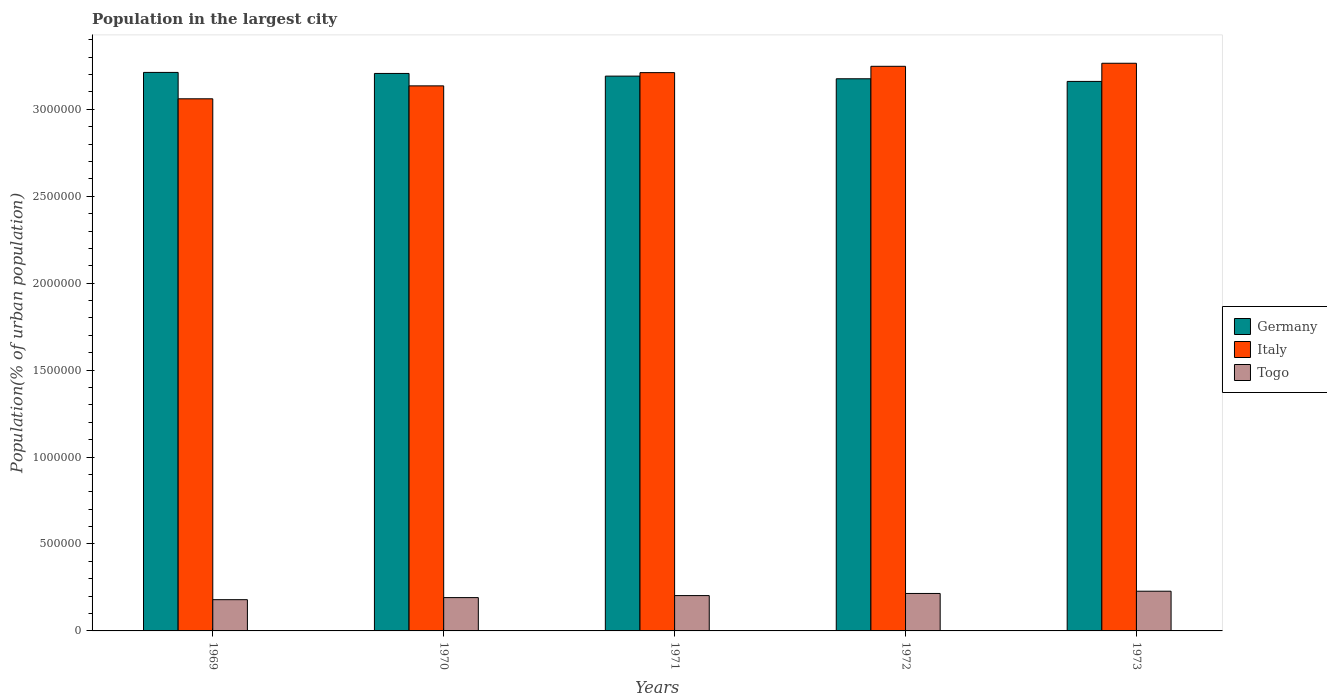How many groups of bars are there?
Your response must be concise. 5. Are the number of bars per tick equal to the number of legend labels?
Make the answer very short. Yes. Are the number of bars on each tick of the X-axis equal?
Offer a terse response. Yes. How many bars are there on the 1st tick from the right?
Your answer should be very brief. 3. In how many cases, is the number of bars for a given year not equal to the number of legend labels?
Keep it short and to the point. 0. What is the population in the largest city in Italy in 1971?
Make the answer very short. 3.21e+06. Across all years, what is the maximum population in the largest city in Italy?
Your answer should be very brief. 3.26e+06. Across all years, what is the minimum population in the largest city in Togo?
Offer a terse response. 1.80e+05. In which year was the population in the largest city in Italy minimum?
Offer a very short reply. 1969. What is the total population in the largest city in Togo in the graph?
Ensure brevity in your answer.  1.02e+06. What is the difference between the population in the largest city in Germany in 1970 and that in 1972?
Make the answer very short. 3.06e+04. What is the difference between the population in the largest city in Togo in 1973 and the population in the largest city in Italy in 1971?
Make the answer very short. -2.98e+06. What is the average population in the largest city in Germany per year?
Offer a terse response. 3.19e+06. In the year 1973, what is the difference between the population in the largest city in Togo and population in the largest city in Germany?
Give a very brief answer. -2.93e+06. What is the ratio of the population in the largest city in Italy in 1969 to that in 1972?
Your answer should be compact. 0.94. What is the difference between the highest and the second highest population in the largest city in Germany?
Keep it short and to the point. 5972. What is the difference between the highest and the lowest population in the largest city in Togo?
Keep it short and to the point. 4.87e+04. What does the 3rd bar from the left in 1970 represents?
Offer a very short reply. Togo. What does the 1st bar from the right in 1970 represents?
Your answer should be compact. Togo. How many years are there in the graph?
Provide a succinct answer. 5. What is the difference between two consecutive major ticks on the Y-axis?
Keep it short and to the point. 5.00e+05. Where does the legend appear in the graph?
Your answer should be compact. Center right. How are the legend labels stacked?
Provide a short and direct response. Vertical. What is the title of the graph?
Ensure brevity in your answer.  Population in the largest city. What is the label or title of the X-axis?
Ensure brevity in your answer.  Years. What is the label or title of the Y-axis?
Offer a very short reply. Population(% of urban population). What is the Population(% of urban population) in Germany in 1969?
Keep it short and to the point. 3.21e+06. What is the Population(% of urban population) of Italy in 1969?
Your response must be concise. 3.06e+06. What is the Population(% of urban population) in Togo in 1969?
Your answer should be compact. 1.80e+05. What is the Population(% of urban population) of Germany in 1970?
Keep it short and to the point. 3.21e+06. What is the Population(% of urban population) of Italy in 1970?
Make the answer very short. 3.13e+06. What is the Population(% of urban population) in Togo in 1970?
Offer a very short reply. 1.92e+05. What is the Population(% of urban population) of Germany in 1971?
Offer a terse response. 3.19e+06. What is the Population(% of urban population) of Italy in 1971?
Make the answer very short. 3.21e+06. What is the Population(% of urban population) of Togo in 1971?
Provide a short and direct response. 2.03e+05. What is the Population(% of urban population) of Germany in 1972?
Keep it short and to the point. 3.18e+06. What is the Population(% of urban population) in Italy in 1972?
Provide a short and direct response. 3.25e+06. What is the Population(% of urban population) in Togo in 1972?
Ensure brevity in your answer.  2.15e+05. What is the Population(% of urban population) of Germany in 1973?
Ensure brevity in your answer.  3.16e+06. What is the Population(% of urban population) in Italy in 1973?
Your answer should be very brief. 3.26e+06. What is the Population(% of urban population) in Togo in 1973?
Give a very brief answer. 2.28e+05. Across all years, what is the maximum Population(% of urban population) of Germany?
Provide a succinct answer. 3.21e+06. Across all years, what is the maximum Population(% of urban population) of Italy?
Your answer should be very brief. 3.26e+06. Across all years, what is the maximum Population(% of urban population) in Togo?
Keep it short and to the point. 2.28e+05. Across all years, what is the minimum Population(% of urban population) of Germany?
Your answer should be very brief. 3.16e+06. Across all years, what is the minimum Population(% of urban population) in Italy?
Provide a short and direct response. 3.06e+06. Across all years, what is the minimum Population(% of urban population) in Togo?
Provide a short and direct response. 1.80e+05. What is the total Population(% of urban population) of Germany in the graph?
Your answer should be very brief. 1.59e+07. What is the total Population(% of urban population) in Italy in the graph?
Your answer should be compact. 1.59e+07. What is the total Population(% of urban population) of Togo in the graph?
Ensure brevity in your answer.  1.02e+06. What is the difference between the Population(% of urban population) of Germany in 1969 and that in 1970?
Give a very brief answer. 5972. What is the difference between the Population(% of urban population) in Italy in 1969 and that in 1970?
Your answer should be compact. -7.44e+04. What is the difference between the Population(% of urban population) of Togo in 1969 and that in 1970?
Offer a terse response. -1.20e+04. What is the difference between the Population(% of urban population) of Germany in 1969 and that in 1971?
Your answer should be compact. 2.13e+04. What is the difference between the Population(% of urban population) of Italy in 1969 and that in 1971?
Your response must be concise. -1.51e+05. What is the difference between the Population(% of urban population) in Togo in 1969 and that in 1971?
Your response must be concise. -2.35e+04. What is the difference between the Population(% of urban population) of Germany in 1969 and that in 1972?
Offer a terse response. 3.66e+04. What is the difference between the Population(% of urban population) in Italy in 1969 and that in 1972?
Your answer should be compact. -1.87e+05. What is the difference between the Population(% of urban population) of Togo in 1969 and that in 1972?
Make the answer very short. -3.58e+04. What is the difference between the Population(% of urban population) of Germany in 1969 and that in 1973?
Ensure brevity in your answer.  5.18e+04. What is the difference between the Population(% of urban population) of Italy in 1969 and that in 1973?
Provide a succinct answer. -2.04e+05. What is the difference between the Population(% of urban population) in Togo in 1969 and that in 1973?
Provide a succinct answer. -4.87e+04. What is the difference between the Population(% of urban population) in Germany in 1970 and that in 1971?
Your answer should be compact. 1.53e+04. What is the difference between the Population(% of urban population) in Italy in 1970 and that in 1971?
Ensure brevity in your answer.  -7.62e+04. What is the difference between the Population(% of urban population) of Togo in 1970 and that in 1971?
Make the answer very short. -1.15e+04. What is the difference between the Population(% of urban population) in Germany in 1970 and that in 1972?
Make the answer very short. 3.06e+04. What is the difference between the Population(% of urban population) in Italy in 1970 and that in 1972?
Your answer should be compact. -1.13e+05. What is the difference between the Population(% of urban population) in Togo in 1970 and that in 1972?
Your answer should be very brief. -2.38e+04. What is the difference between the Population(% of urban population) of Germany in 1970 and that in 1973?
Ensure brevity in your answer.  4.58e+04. What is the difference between the Population(% of urban population) in Italy in 1970 and that in 1973?
Make the answer very short. -1.30e+05. What is the difference between the Population(% of urban population) in Togo in 1970 and that in 1973?
Offer a very short reply. -3.68e+04. What is the difference between the Population(% of urban population) of Germany in 1971 and that in 1972?
Your answer should be very brief. 1.53e+04. What is the difference between the Population(% of urban population) in Italy in 1971 and that in 1972?
Provide a short and direct response. -3.64e+04. What is the difference between the Population(% of urban population) in Togo in 1971 and that in 1972?
Give a very brief answer. -1.23e+04. What is the difference between the Population(% of urban population) in Germany in 1971 and that in 1973?
Offer a terse response. 3.05e+04. What is the difference between the Population(% of urban population) of Italy in 1971 and that in 1973?
Ensure brevity in your answer.  -5.39e+04. What is the difference between the Population(% of urban population) of Togo in 1971 and that in 1973?
Provide a short and direct response. -2.52e+04. What is the difference between the Population(% of urban population) in Germany in 1972 and that in 1973?
Your answer should be very brief. 1.52e+04. What is the difference between the Population(% of urban population) in Italy in 1972 and that in 1973?
Ensure brevity in your answer.  -1.75e+04. What is the difference between the Population(% of urban population) in Togo in 1972 and that in 1973?
Your response must be concise. -1.30e+04. What is the difference between the Population(% of urban population) of Germany in 1969 and the Population(% of urban population) of Italy in 1970?
Make the answer very short. 7.75e+04. What is the difference between the Population(% of urban population) of Germany in 1969 and the Population(% of urban population) of Togo in 1970?
Your response must be concise. 3.02e+06. What is the difference between the Population(% of urban population) of Italy in 1969 and the Population(% of urban population) of Togo in 1970?
Your answer should be very brief. 2.87e+06. What is the difference between the Population(% of urban population) in Germany in 1969 and the Population(% of urban population) in Italy in 1971?
Make the answer very short. 1280. What is the difference between the Population(% of urban population) of Germany in 1969 and the Population(% of urban population) of Togo in 1971?
Keep it short and to the point. 3.01e+06. What is the difference between the Population(% of urban population) of Italy in 1969 and the Population(% of urban population) of Togo in 1971?
Keep it short and to the point. 2.86e+06. What is the difference between the Population(% of urban population) of Germany in 1969 and the Population(% of urban population) of Italy in 1972?
Provide a short and direct response. -3.51e+04. What is the difference between the Population(% of urban population) in Germany in 1969 and the Population(% of urban population) in Togo in 1972?
Your response must be concise. 3.00e+06. What is the difference between the Population(% of urban population) in Italy in 1969 and the Population(% of urban population) in Togo in 1972?
Your answer should be very brief. 2.85e+06. What is the difference between the Population(% of urban population) in Germany in 1969 and the Population(% of urban population) in Italy in 1973?
Offer a very short reply. -5.26e+04. What is the difference between the Population(% of urban population) in Germany in 1969 and the Population(% of urban population) in Togo in 1973?
Your answer should be compact. 2.98e+06. What is the difference between the Population(% of urban population) of Italy in 1969 and the Population(% of urban population) of Togo in 1973?
Offer a very short reply. 2.83e+06. What is the difference between the Population(% of urban population) of Germany in 1970 and the Population(% of urban population) of Italy in 1971?
Your answer should be compact. -4692. What is the difference between the Population(% of urban population) of Germany in 1970 and the Population(% of urban population) of Togo in 1971?
Ensure brevity in your answer.  3.00e+06. What is the difference between the Population(% of urban population) of Italy in 1970 and the Population(% of urban population) of Togo in 1971?
Your response must be concise. 2.93e+06. What is the difference between the Population(% of urban population) of Germany in 1970 and the Population(% of urban population) of Italy in 1972?
Give a very brief answer. -4.11e+04. What is the difference between the Population(% of urban population) in Germany in 1970 and the Population(% of urban population) in Togo in 1972?
Provide a succinct answer. 2.99e+06. What is the difference between the Population(% of urban population) of Italy in 1970 and the Population(% of urban population) of Togo in 1972?
Make the answer very short. 2.92e+06. What is the difference between the Population(% of urban population) of Germany in 1970 and the Population(% of urban population) of Italy in 1973?
Your answer should be compact. -5.86e+04. What is the difference between the Population(% of urban population) of Germany in 1970 and the Population(% of urban population) of Togo in 1973?
Offer a very short reply. 2.98e+06. What is the difference between the Population(% of urban population) in Italy in 1970 and the Population(% of urban population) in Togo in 1973?
Offer a terse response. 2.91e+06. What is the difference between the Population(% of urban population) in Germany in 1971 and the Population(% of urban population) in Italy in 1972?
Provide a short and direct response. -5.64e+04. What is the difference between the Population(% of urban population) of Germany in 1971 and the Population(% of urban population) of Togo in 1972?
Your answer should be very brief. 2.98e+06. What is the difference between the Population(% of urban population) of Italy in 1971 and the Population(% of urban population) of Togo in 1972?
Your answer should be compact. 3.00e+06. What is the difference between the Population(% of urban population) in Germany in 1971 and the Population(% of urban population) in Italy in 1973?
Keep it short and to the point. -7.39e+04. What is the difference between the Population(% of urban population) in Germany in 1971 and the Population(% of urban population) in Togo in 1973?
Keep it short and to the point. 2.96e+06. What is the difference between the Population(% of urban population) of Italy in 1971 and the Population(% of urban population) of Togo in 1973?
Provide a short and direct response. 2.98e+06. What is the difference between the Population(% of urban population) in Germany in 1972 and the Population(% of urban population) in Italy in 1973?
Provide a short and direct response. -8.92e+04. What is the difference between the Population(% of urban population) of Germany in 1972 and the Population(% of urban population) of Togo in 1973?
Provide a succinct answer. 2.95e+06. What is the difference between the Population(% of urban population) in Italy in 1972 and the Population(% of urban population) in Togo in 1973?
Your response must be concise. 3.02e+06. What is the average Population(% of urban population) of Germany per year?
Your answer should be very brief. 3.19e+06. What is the average Population(% of urban population) of Italy per year?
Give a very brief answer. 3.18e+06. What is the average Population(% of urban population) of Togo per year?
Provide a succinct answer. 2.04e+05. In the year 1969, what is the difference between the Population(% of urban population) in Germany and Population(% of urban population) in Italy?
Ensure brevity in your answer.  1.52e+05. In the year 1969, what is the difference between the Population(% of urban population) of Germany and Population(% of urban population) of Togo?
Ensure brevity in your answer.  3.03e+06. In the year 1969, what is the difference between the Population(% of urban population) in Italy and Population(% of urban population) in Togo?
Provide a succinct answer. 2.88e+06. In the year 1970, what is the difference between the Population(% of urban population) in Germany and Population(% of urban population) in Italy?
Provide a succinct answer. 7.15e+04. In the year 1970, what is the difference between the Population(% of urban population) in Germany and Population(% of urban population) in Togo?
Offer a terse response. 3.01e+06. In the year 1970, what is the difference between the Population(% of urban population) of Italy and Population(% of urban population) of Togo?
Your answer should be compact. 2.94e+06. In the year 1971, what is the difference between the Population(% of urban population) in Germany and Population(% of urban population) in Italy?
Make the answer very short. -2.00e+04. In the year 1971, what is the difference between the Population(% of urban population) of Germany and Population(% of urban population) of Togo?
Your answer should be compact. 2.99e+06. In the year 1971, what is the difference between the Population(% of urban population) in Italy and Population(% of urban population) in Togo?
Keep it short and to the point. 3.01e+06. In the year 1972, what is the difference between the Population(% of urban population) of Germany and Population(% of urban population) of Italy?
Offer a very short reply. -7.17e+04. In the year 1972, what is the difference between the Population(% of urban population) in Germany and Population(% of urban population) in Togo?
Provide a succinct answer. 2.96e+06. In the year 1972, what is the difference between the Population(% of urban population) of Italy and Population(% of urban population) of Togo?
Provide a succinct answer. 3.03e+06. In the year 1973, what is the difference between the Population(% of urban population) in Germany and Population(% of urban population) in Italy?
Offer a very short reply. -1.04e+05. In the year 1973, what is the difference between the Population(% of urban population) of Germany and Population(% of urban population) of Togo?
Give a very brief answer. 2.93e+06. In the year 1973, what is the difference between the Population(% of urban population) in Italy and Population(% of urban population) in Togo?
Ensure brevity in your answer.  3.04e+06. What is the ratio of the Population(% of urban population) in Germany in 1969 to that in 1970?
Your response must be concise. 1. What is the ratio of the Population(% of urban population) in Italy in 1969 to that in 1970?
Provide a succinct answer. 0.98. What is the ratio of the Population(% of urban population) in Togo in 1969 to that in 1970?
Keep it short and to the point. 0.94. What is the ratio of the Population(% of urban population) in Germany in 1969 to that in 1971?
Keep it short and to the point. 1.01. What is the ratio of the Population(% of urban population) in Italy in 1969 to that in 1971?
Provide a succinct answer. 0.95. What is the ratio of the Population(% of urban population) of Togo in 1969 to that in 1971?
Provide a succinct answer. 0.88. What is the ratio of the Population(% of urban population) of Germany in 1969 to that in 1972?
Your answer should be compact. 1.01. What is the ratio of the Population(% of urban population) of Italy in 1969 to that in 1972?
Your answer should be very brief. 0.94. What is the ratio of the Population(% of urban population) in Togo in 1969 to that in 1972?
Your answer should be compact. 0.83. What is the ratio of the Population(% of urban population) of Germany in 1969 to that in 1973?
Offer a terse response. 1.02. What is the ratio of the Population(% of urban population) in Italy in 1969 to that in 1973?
Your answer should be compact. 0.94. What is the ratio of the Population(% of urban population) in Togo in 1969 to that in 1973?
Ensure brevity in your answer.  0.79. What is the ratio of the Population(% of urban population) in Italy in 1970 to that in 1971?
Offer a terse response. 0.98. What is the ratio of the Population(% of urban population) in Togo in 1970 to that in 1971?
Your answer should be compact. 0.94. What is the ratio of the Population(% of urban population) of Germany in 1970 to that in 1972?
Keep it short and to the point. 1.01. What is the ratio of the Population(% of urban population) of Italy in 1970 to that in 1972?
Offer a terse response. 0.97. What is the ratio of the Population(% of urban population) of Togo in 1970 to that in 1972?
Provide a succinct answer. 0.89. What is the ratio of the Population(% of urban population) in Germany in 1970 to that in 1973?
Your answer should be compact. 1.01. What is the ratio of the Population(% of urban population) of Italy in 1970 to that in 1973?
Ensure brevity in your answer.  0.96. What is the ratio of the Population(% of urban population) of Togo in 1970 to that in 1973?
Keep it short and to the point. 0.84. What is the ratio of the Population(% of urban population) of Italy in 1971 to that in 1972?
Your response must be concise. 0.99. What is the ratio of the Population(% of urban population) of Togo in 1971 to that in 1972?
Provide a short and direct response. 0.94. What is the ratio of the Population(% of urban population) of Germany in 1971 to that in 1973?
Offer a terse response. 1.01. What is the ratio of the Population(% of urban population) of Italy in 1971 to that in 1973?
Your response must be concise. 0.98. What is the ratio of the Population(% of urban population) in Togo in 1971 to that in 1973?
Provide a succinct answer. 0.89. What is the ratio of the Population(% of urban population) in Togo in 1972 to that in 1973?
Provide a succinct answer. 0.94. What is the difference between the highest and the second highest Population(% of urban population) in Germany?
Ensure brevity in your answer.  5972. What is the difference between the highest and the second highest Population(% of urban population) of Italy?
Give a very brief answer. 1.75e+04. What is the difference between the highest and the second highest Population(% of urban population) in Togo?
Keep it short and to the point. 1.30e+04. What is the difference between the highest and the lowest Population(% of urban population) of Germany?
Offer a very short reply. 5.18e+04. What is the difference between the highest and the lowest Population(% of urban population) in Italy?
Provide a succinct answer. 2.04e+05. What is the difference between the highest and the lowest Population(% of urban population) in Togo?
Offer a very short reply. 4.87e+04. 